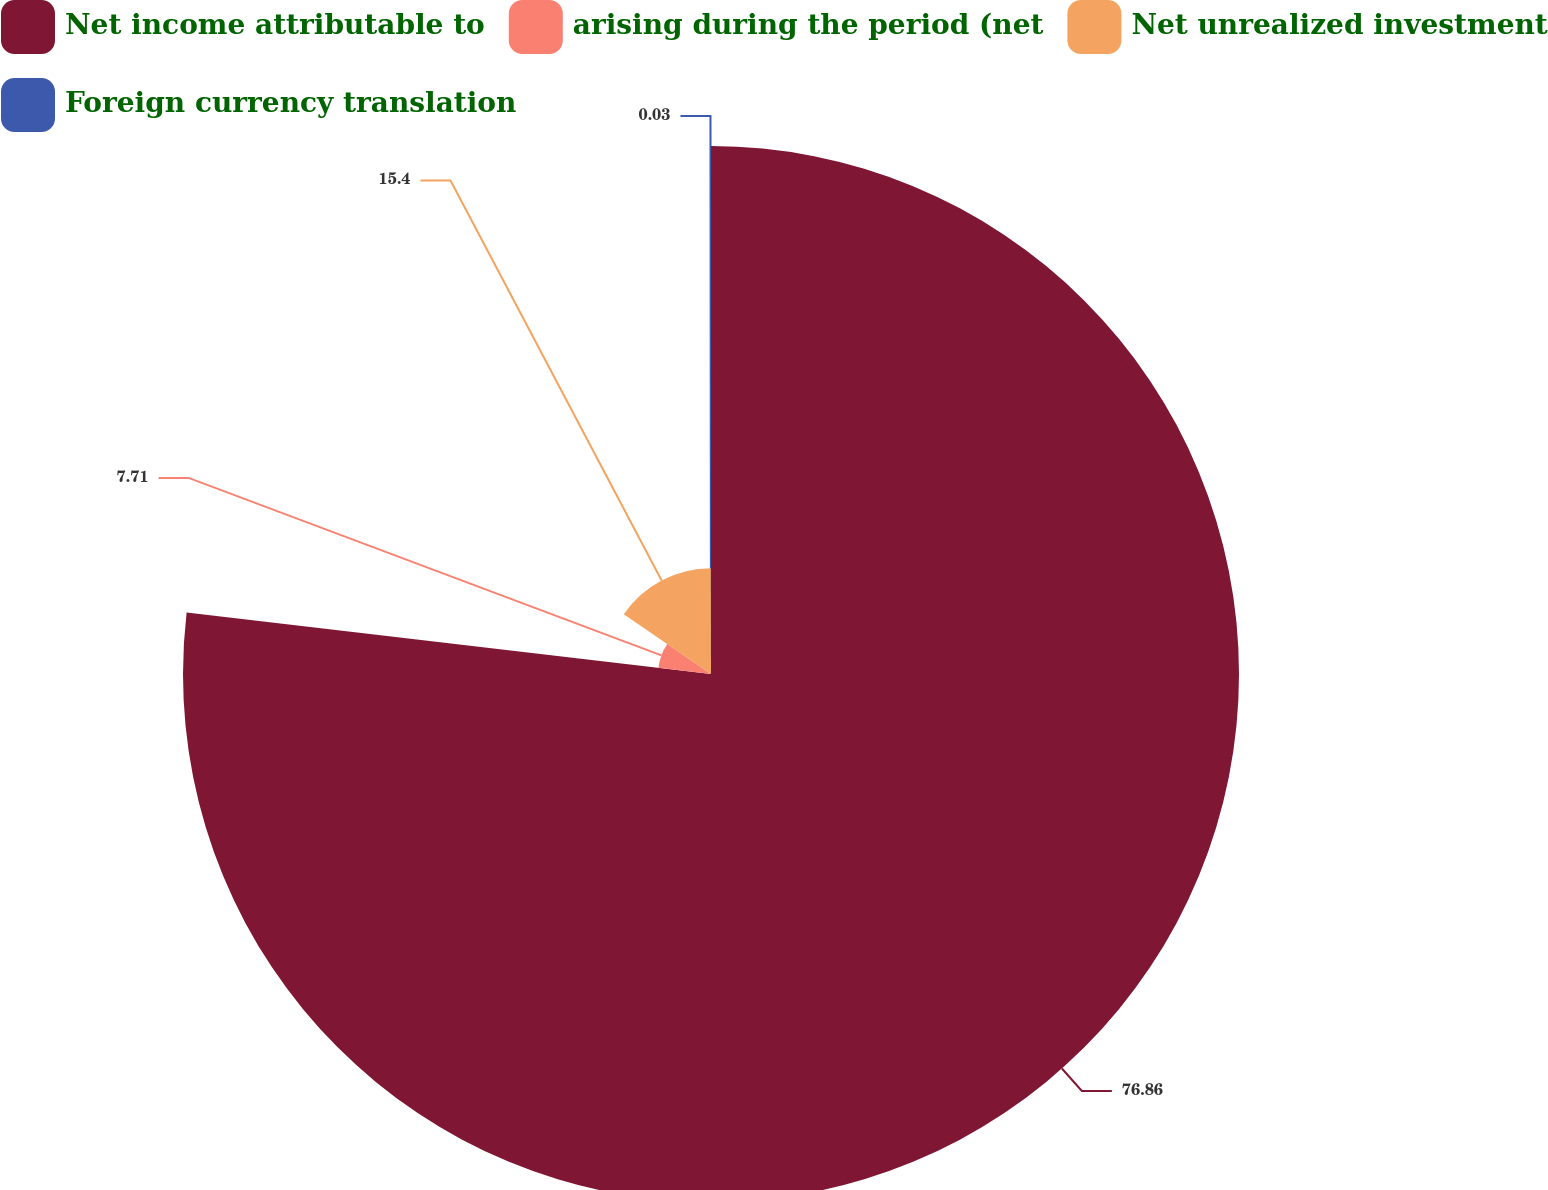Convert chart. <chart><loc_0><loc_0><loc_500><loc_500><pie_chart><fcel>Net income attributable to<fcel>arising during the period (net<fcel>Net unrealized investment<fcel>Foreign currency translation<nl><fcel>76.86%<fcel>7.71%<fcel>15.4%<fcel>0.03%<nl></chart> 